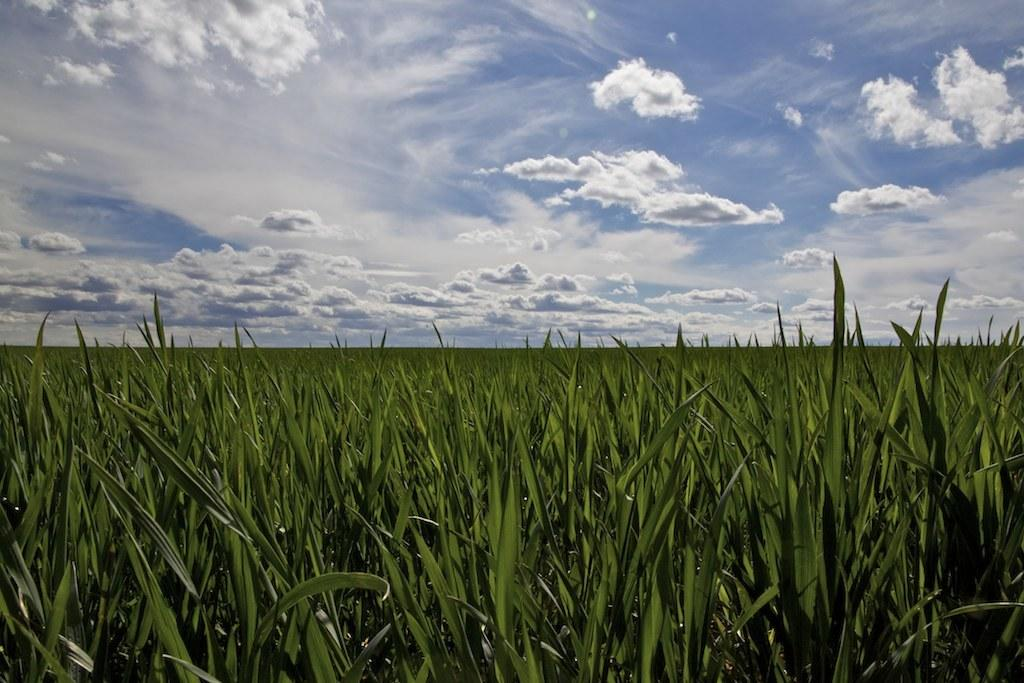What type of vegetation is present in the image? There is green-colored grass in the image. How would you describe the color of the sky in the image? The sky is a combination of white and blue colors in the image. Where is the dock located in the image? There is no dock present in the image. How does the grip of the grass feel in the image? The image is a visual representation, and we cannot determine the tactile sensation of the grass from the image alone. 